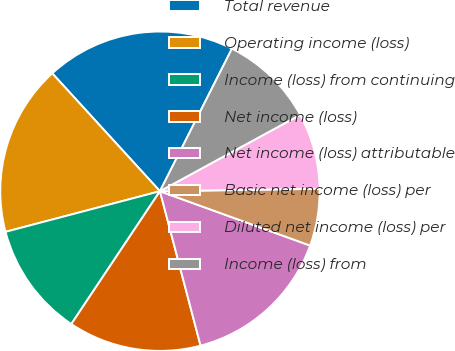Convert chart. <chart><loc_0><loc_0><loc_500><loc_500><pie_chart><fcel>Total revenue<fcel>Operating income (loss)<fcel>Income (loss) from continuing<fcel>Net income (loss)<fcel>Net income (loss) attributable<fcel>Basic net income (loss) per<fcel>Diluted net income (loss) per<fcel>Income (loss) from<nl><fcel>19.23%<fcel>17.31%<fcel>11.54%<fcel>13.46%<fcel>15.38%<fcel>5.77%<fcel>7.69%<fcel>9.62%<nl></chart> 